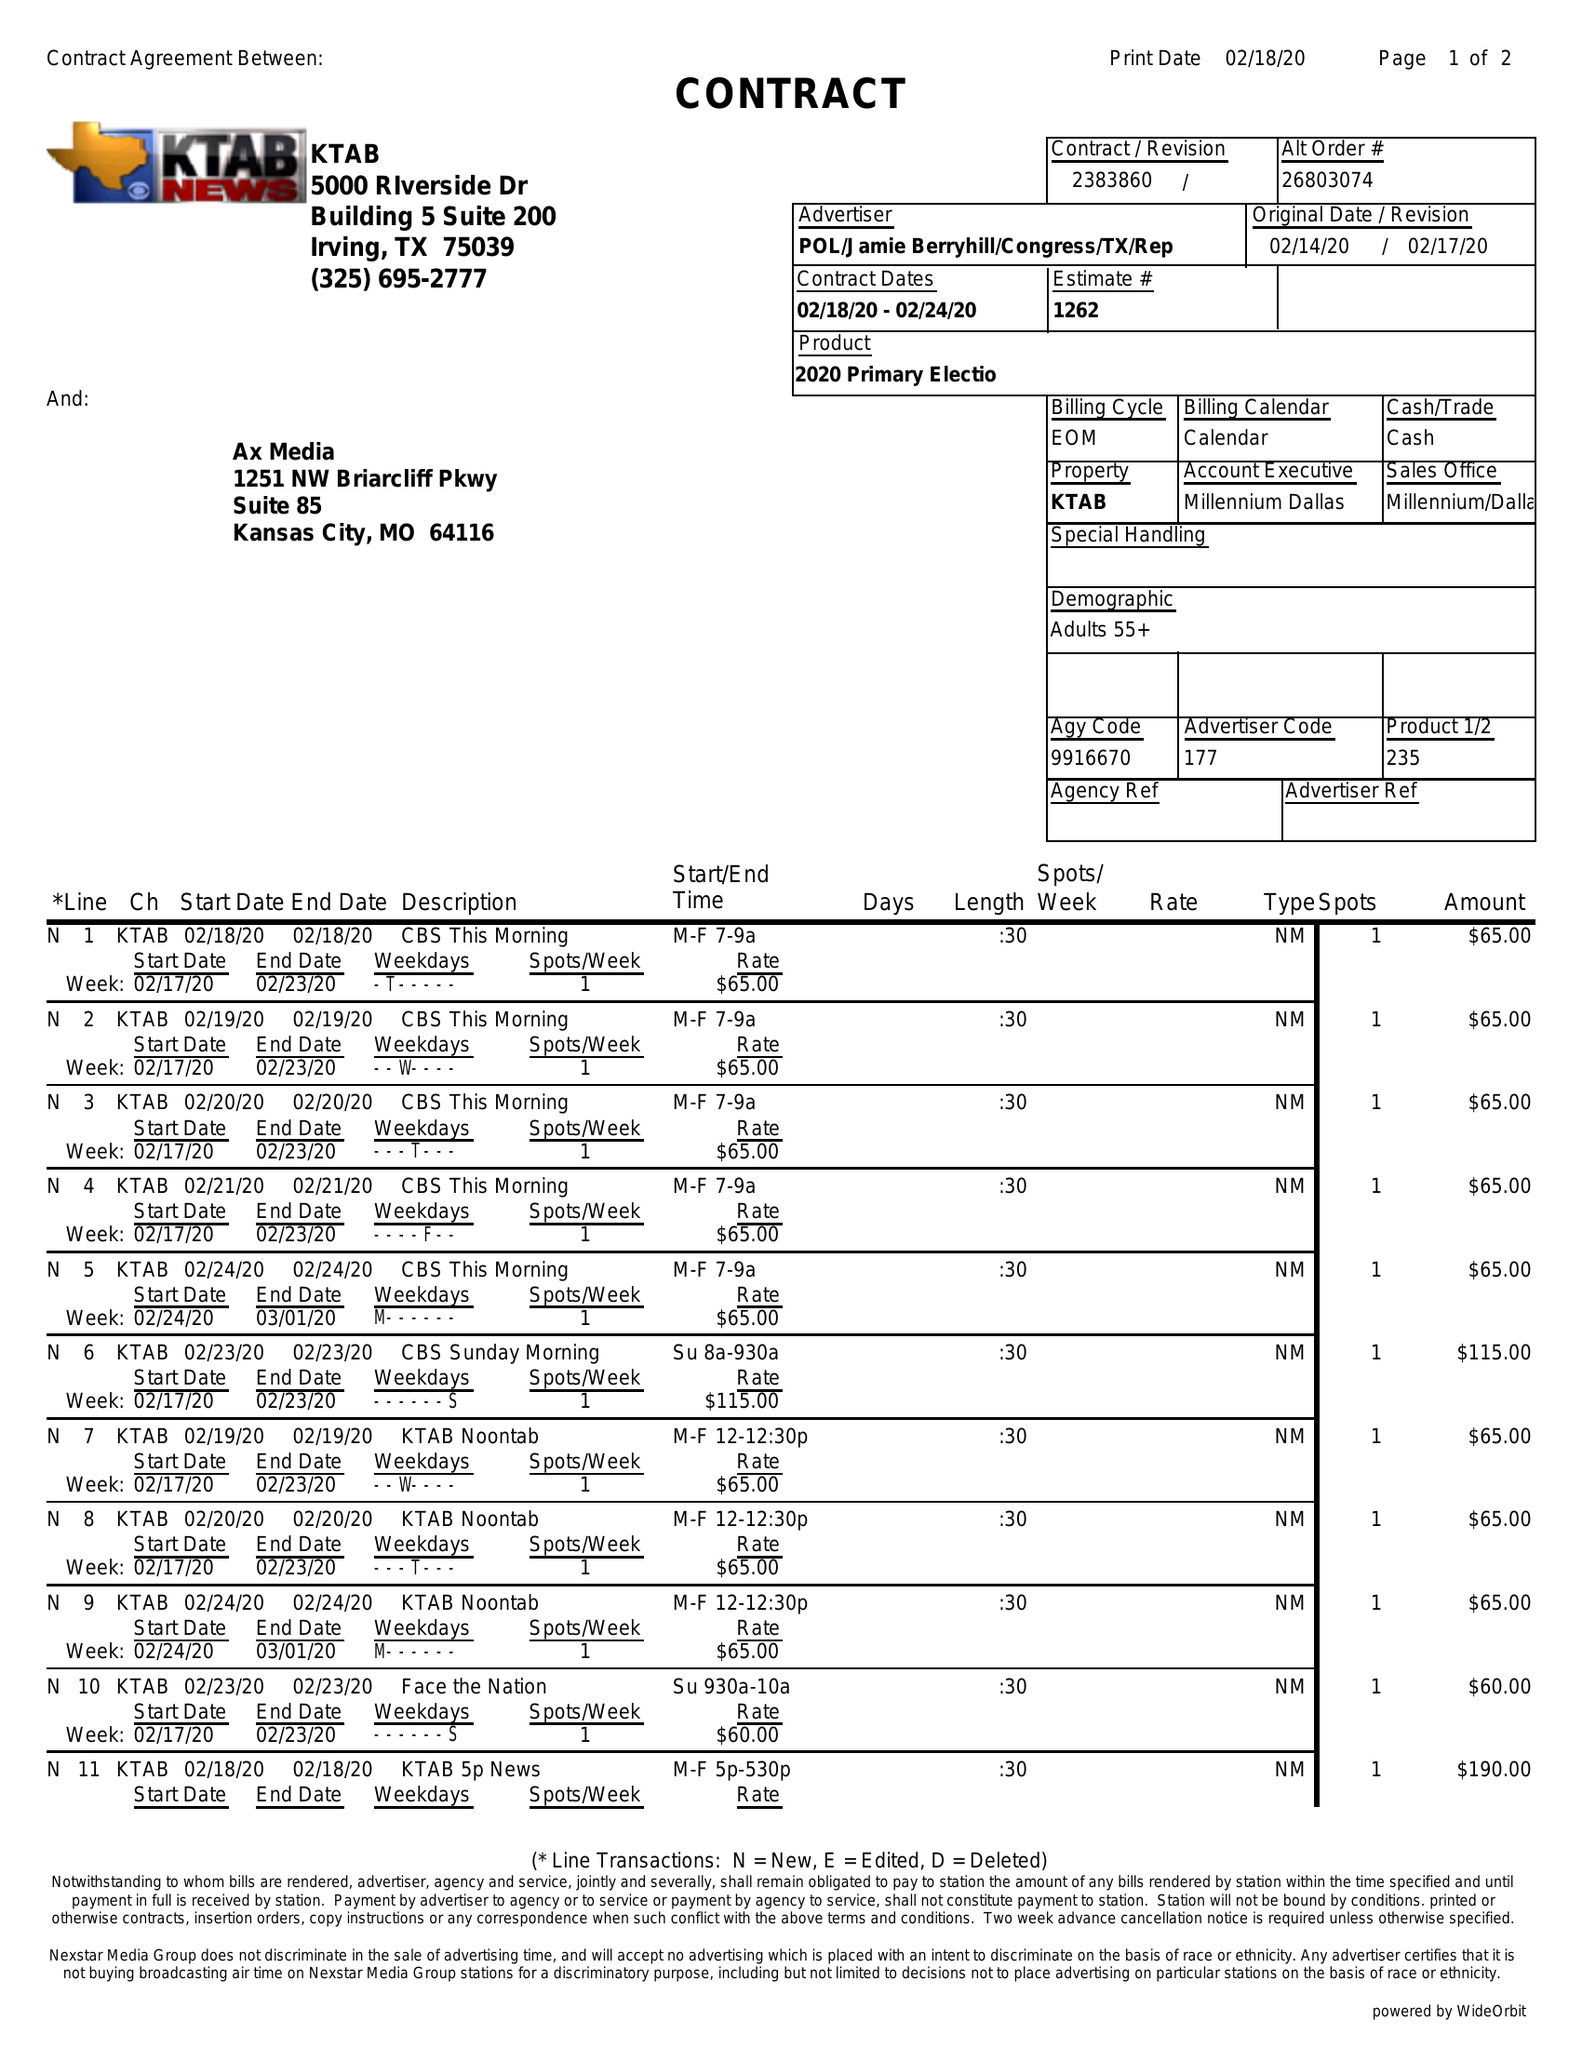What is the value for the contract_num?
Answer the question using a single word or phrase. 2383860 